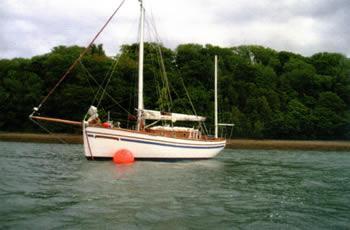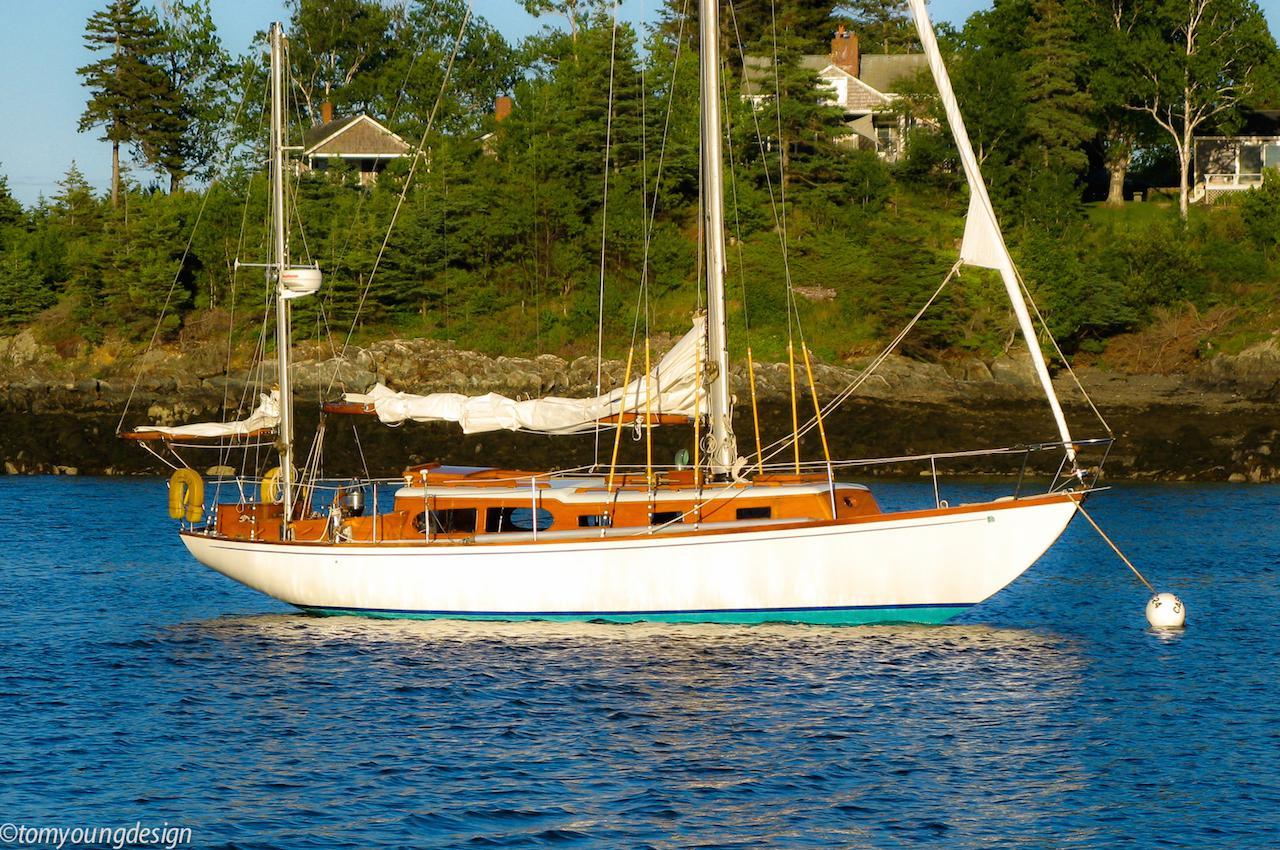The first image is the image on the left, the second image is the image on the right. Considering the images on both sides, is "in at least one image there is a single  boat with 3 sails" valid? Answer yes or no. No. 